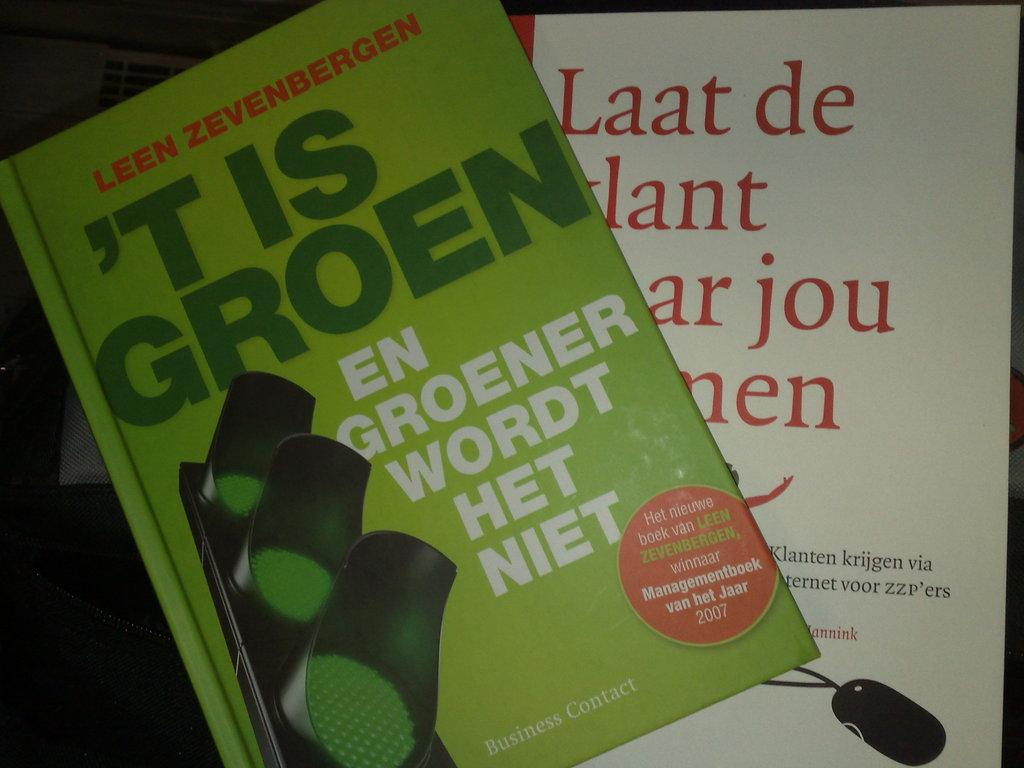<image>
Present a compact description of the photo's key features. a book by leen zevenbergen titled ''t is groen' 